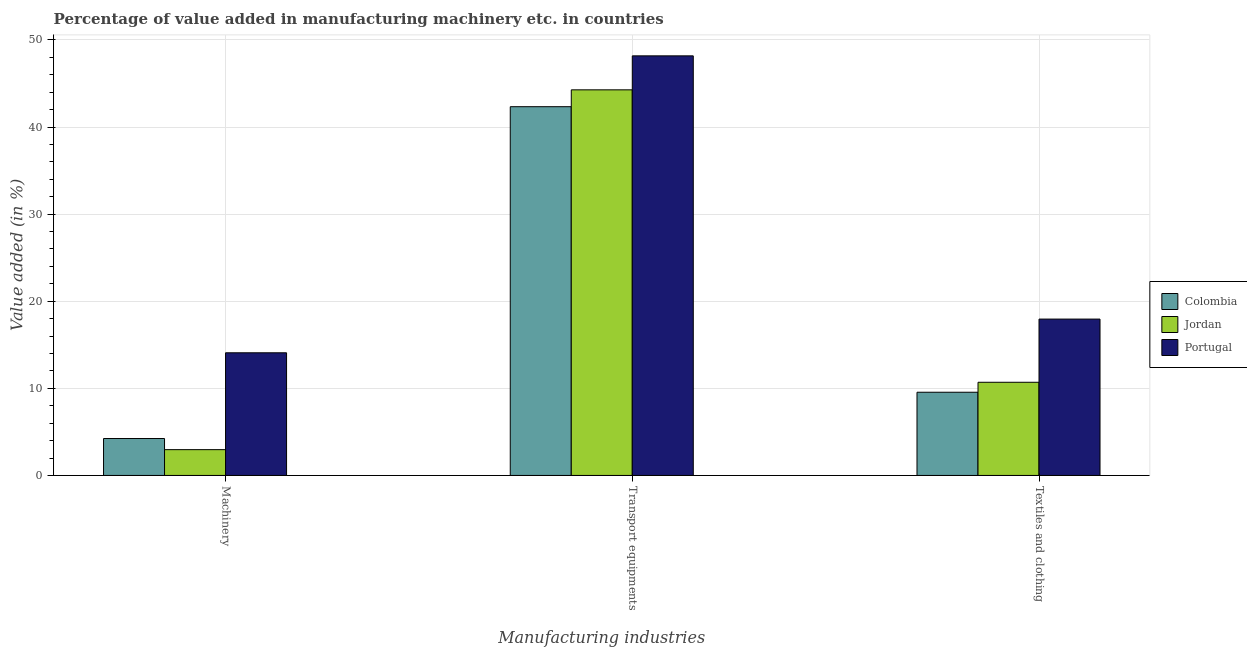How many groups of bars are there?
Keep it short and to the point. 3. Are the number of bars per tick equal to the number of legend labels?
Your answer should be compact. Yes. Are the number of bars on each tick of the X-axis equal?
Ensure brevity in your answer.  Yes. How many bars are there on the 3rd tick from the right?
Provide a short and direct response. 3. What is the label of the 3rd group of bars from the left?
Make the answer very short. Textiles and clothing. What is the value added in manufacturing transport equipments in Jordan?
Provide a short and direct response. 44.27. Across all countries, what is the maximum value added in manufacturing transport equipments?
Provide a short and direct response. 48.17. Across all countries, what is the minimum value added in manufacturing transport equipments?
Make the answer very short. 42.33. What is the total value added in manufacturing machinery in the graph?
Your response must be concise. 21.28. What is the difference between the value added in manufacturing transport equipments in Portugal and that in Colombia?
Your response must be concise. 5.84. What is the difference between the value added in manufacturing textile and clothing in Colombia and the value added in manufacturing transport equipments in Jordan?
Offer a very short reply. -34.72. What is the average value added in manufacturing textile and clothing per country?
Offer a very short reply. 12.73. What is the difference between the value added in manufacturing machinery and value added in manufacturing textile and clothing in Colombia?
Give a very brief answer. -5.31. In how many countries, is the value added in manufacturing textile and clothing greater than 20 %?
Give a very brief answer. 0. What is the ratio of the value added in manufacturing machinery in Colombia to that in Portugal?
Provide a short and direct response. 0.3. Is the value added in manufacturing textile and clothing in Jordan less than that in Colombia?
Make the answer very short. No. Is the difference between the value added in manufacturing transport equipments in Portugal and Colombia greater than the difference between the value added in manufacturing machinery in Portugal and Colombia?
Ensure brevity in your answer.  No. What is the difference between the highest and the second highest value added in manufacturing machinery?
Give a very brief answer. 9.84. What is the difference between the highest and the lowest value added in manufacturing transport equipments?
Give a very brief answer. 5.84. In how many countries, is the value added in manufacturing textile and clothing greater than the average value added in manufacturing textile and clothing taken over all countries?
Your answer should be compact. 1. Is the sum of the value added in manufacturing textile and clothing in Portugal and Colombia greater than the maximum value added in manufacturing transport equipments across all countries?
Ensure brevity in your answer.  No. What does the 2nd bar from the left in Machinery represents?
Your answer should be compact. Jordan. What does the 1st bar from the right in Textiles and clothing represents?
Provide a succinct answer. Portugal. Is it the case that in every country, the sum of the value added in manufacturing machinery and value added in manufacturing transport equipments is greater than the value added in manufacturing textile and clothing?
Give a very brief answer. Yes. How many bars are there?
Offer a very short reply. 9. Are all the bars in the graph horizontal?
Give a very brief answer. No. Are the values on the major ticks of Y-axis written in scientific E-notation?
Your answer should be compact. No. Does the graph contain any zero values?
Give a very brief answer. No. How are the legend labels stacked?
Provide a succinct answer. Vertical. What is the title of the graph?
Offer a terse response. Percentage of value added in manufacturing machinery etc. in countries. What is the label or title of the X-axis?
Give a very brief answer. Manufacturing industries. What is the label or title of the Y-axis?
Keep it short and to the point. Value added (in %). What is the Value added (in %) in Colombia in Machinery?
Your answer should be compact. 4.24. What is the Value added (in %) of Jordan in Machinery?
Ensure brevity in your answer.  2.96. What is the Value added (in %) in Portugal in Machinery?
Your answer should be compact. 14.08. What is the Value added (in %) of Colombia in Transport equipments?
Give a very brief answer. 42.33. What is the Value added (in %) of Jordan in Transport equipments?
Offer a terse response. 44.27. What is the Value added (in %) in Portugal in Transport equipments?
Your answer should be very brief. 48.17. What is the Value added (in %) in Colombia in Textiles and clothing?
Your answer should be compact. 9.55. What is the Value added (in %) in Jordan in Textiles and clothing?
Offer a very short reply. 10.7. What is the Value added (in %) in Portugal in Textiles and clothing?
Give a very brief answer. 17.95. Across all Manufacturing industries, what is the maximum Value added (in %) in Colombia?
Give a very brief answer. 42.33. Across all Manufacturing industries, what is the maximum Value added (in %) in Jordan?
Offer a very short reply. 44.27. Across all Manufacturing industries, what is the maximum Value added (in %) of Portugal?
Ensure brevity in your answer.  48.17. Across all Manufacturing industries, what is the minimum Value added (in %) in Colombia?
Offer a terse response. 4.24. Across all Manufacturing industries, what is the minimum Value added (in %) in Jordan?
Keep it short and to the point. 2.96. Across all Manufacturing industries, what is the minimum Value added (in %) of Portugal?
Your answer should be compact. 14.08. What is the total Value added (in %) in Colombia in the graph?
Your response must be concise. 56.12. What is the total Value added (in %) of Jordan in the graph?
Provide a short and direct response. 57.93. What is the total Value added (in %) in Portugal in the graph?
Your answer should be compact. 80.2. What is the difference between the Value added (in %) in Colombia in Machinery and that in Transport equipments?
Make the answer very short. -38.1. What is the difference between the Value added (in %) of Jordan in Machinery and that in Transport equipments?
Offer a very short reply. -41.31. What is the difference between the Value added (in %) in Portugal in Machinery and that in Transport equipments?
Make the answer very short. -34.09. What is the difference between the Value added (in %) of Colombia in Machinery and that in Textiles and clothing?
Ensure brevity in your answer.  -5.31. What is the difference between the Value added (in %) of Jordan in Machinery and that in Textiles and clothing?
Your response must be concise. -7.74. What is the difference between the Value added (in %) in Portugal in Machinery and that in Textiles and clothing?
Keep it short and to the point. -3.87. What is the difference between the Value added (in %) in Colombia in Transport equipments and that in Textiles and clothing?
Give a very brief answer. 32.78. What is the difference between the Value added (in %) in Jordan in Transport equipments and that in Textiles and clothing?
Your answer should be very brief. 33.57. What is the difference between the Value added (in %) in Portugal in Transport equipments and that in Textiles and clothing?
Provide a succinct answer. 30.22. What is the difference between the Value added (in %) of Colombia in Machinery and the Value added (in %) of Jordan in Transport equipments?
Your response must be concise. -40.03. What is the difference between the Value added (in %) of Colombia in Machinery and the Value added (in %) of Portugal in Transport equipments?
Offer a very short reply. -43.93. What is the difference between the Value added (in %) of Jordan in Machinery and the Value added (in %) of Portugal in Transport equipments?
Provide a succinct answer. -45.21. What is the difference between the Value added (in %) in Colombia in Machinery and the Value added (in %) in Jordan in Textiles and clothing?
Offer a terse response. -6.46. What is the difference between the Value added (in %) of Colombia in Machinery and the Value added (in %) of Portugal in Textiles and clothing?
Provide a short and direct response. -13.71. What is the difference between the Value added (in %) in Jordan in Machinery and the Value added (in %) in Portugal in Textiles and clothing?
Ensure brevity in your answer.  -14.99. What is the difference between the Value added (in %) in Colombia in Transport equipments and the Value added (in %) in Jordan in Textiles and clothing?
Your response must be concise. 31.64. What is the difference between the Value added (in %) of Colombia in Transport equipments and the Value added (in %) of Portugal in Textiles and clothing?
Your response must be concise. 24.38. What is the difference between the Value added (in %) in Jordan in Transport equipments and the Value added (in %) in Portugal in Textiles and clothing?
Provide a succinct answer. 26.32. What is the average Value added (in %) in Colombia per Manufacturing industries?
Your response must be concise. 18.71. What is the average Value added (in %) in Jordan per Manufacturing industries?
Your response must be concise. 19.31. What is the average Value added (in %) in Portugal per Manufacturing industries?
Your answer should be very brief. 26.73. What is the difference between the Value added (in %) of Colombia and Value added (in %) of Jordan in Machinery?
Provide a short and direct response. 1.28. What is the difference between the Value added (in %) of Colombia and Value added (in %) of Portugal in Machinery?
Make the answer very short. -9.84. What is the difference between the Value added (in %) of Jordan and Value added (in %) of Portugal in Machinery?
Provide a short and direct response. -11.12. What is the difference between the Value added (in %) in Colombia and Value added (in %) in Jordan in Transport equipments?
Offer a very short reply. -1.94. What is the difference between the Value added (in %) in Colombia and Value added (in %) in Portugal in Transport equipments?
Keep it short and to the point. -5.84. What is the difference between the Value added (in %) of Jordan and Value added (in %) of Portugal in Transport equipments?
Offer a terse response. -3.9. What is the difference between the Value added (in %) of Colombia and Value added (in %) of Jordan in Textiles and clothing?
Offer a very short reply. -1.15. What is the difference between the Value added (in %) in Colombia and Value added (in %) in Portugal in Textiles and clothing?
Your response must be concise. -8.4. What is the difference between the Value added (in %) of Jordan and Value added (in %) of Portugal in Textiles and clothing?
Offer a terse response. -7.25. What is the ratio of the Value added (in %) of Colombia in Machinery to that in Transport equipments?
Offer a very short reply. 0.1. What is the ratio of the Value added (in %) of Jordan in Machinery to that in Transport equipments?
Offer a very short reply. 0.07. What is the ratio of the Value added (in %) of Portugal in Machinery to that in Transport equipments?
Provide a short and direct response. 0.29. What is the ratio of the Value added (in %) of Colombia in Machinery to that in Textiles and clothing?
Offer a terse response. 0.44. What is the ratio of the Value added (in %) in Jordan in Machinery to that in Textiles and clothing?
Your answer should be very brief. 0.28. What is the ratio of the Value added (in %) in Portugal in Machinery to that in Textiles and clothing?
Offer a very short reply. 0.78. What is the ratio of the Value added (in %) in Colombia in Transport equipments to that in Textiles and clothing?
Provide a short and direct response. 4.43. What is the ratio of the Value added (in %) of Jordan in Transport equipments to that in Textiles and clothing?
Your answer should be very brief. 4.14. What is the ratio of the Value added (in %) in Portugal in Transport equipments to that in Textiles and clothing?
Your response must be concise. 2.68. What is the difference between the highest and the second highest Value added (in %) of Colombia?
Provide a succinct answer. 32.78. What is the difference between the highest and the second highest Value added (in %) of Jordan?
Your answer should be very brief. 33.57. What is the difference between the highest and the second highest Value added (in %) of Portugal?
Your answer should be very brief. 30.22. What is the difference between the highest and the lowest Value added (in %) of Colombia?
Provide a short and direct response. 38.1. What is the difference between the highest and the lowest Value added (in %) of Jordan?
Your answer should be very brief. 41.31. What is the difference between the highest and the lowest Value added (in %) in Portugal?
Offer a terse response. 34.09. 